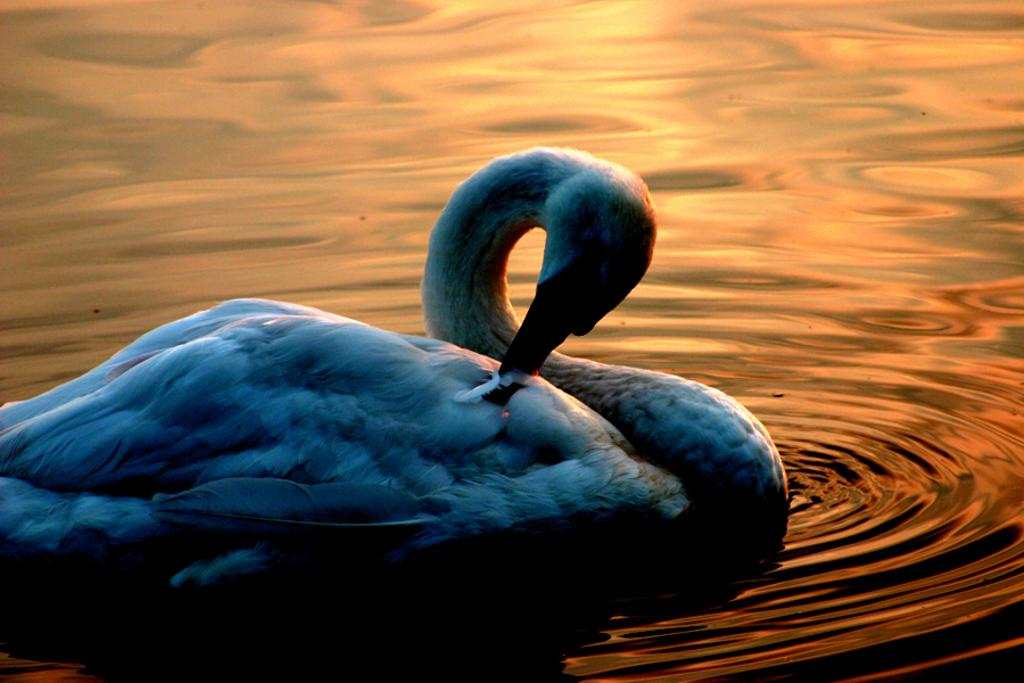What type of animal is in the image? There is a duck in the image. Where is the duck located? The duck is on the water. What can be observed about the water in the image? There are water waves visible in the image. Can you tell me how many fans are visible in the image? There are no fans present in the image. Are there any sheep visible in the image? There are no sheep present in the image. 